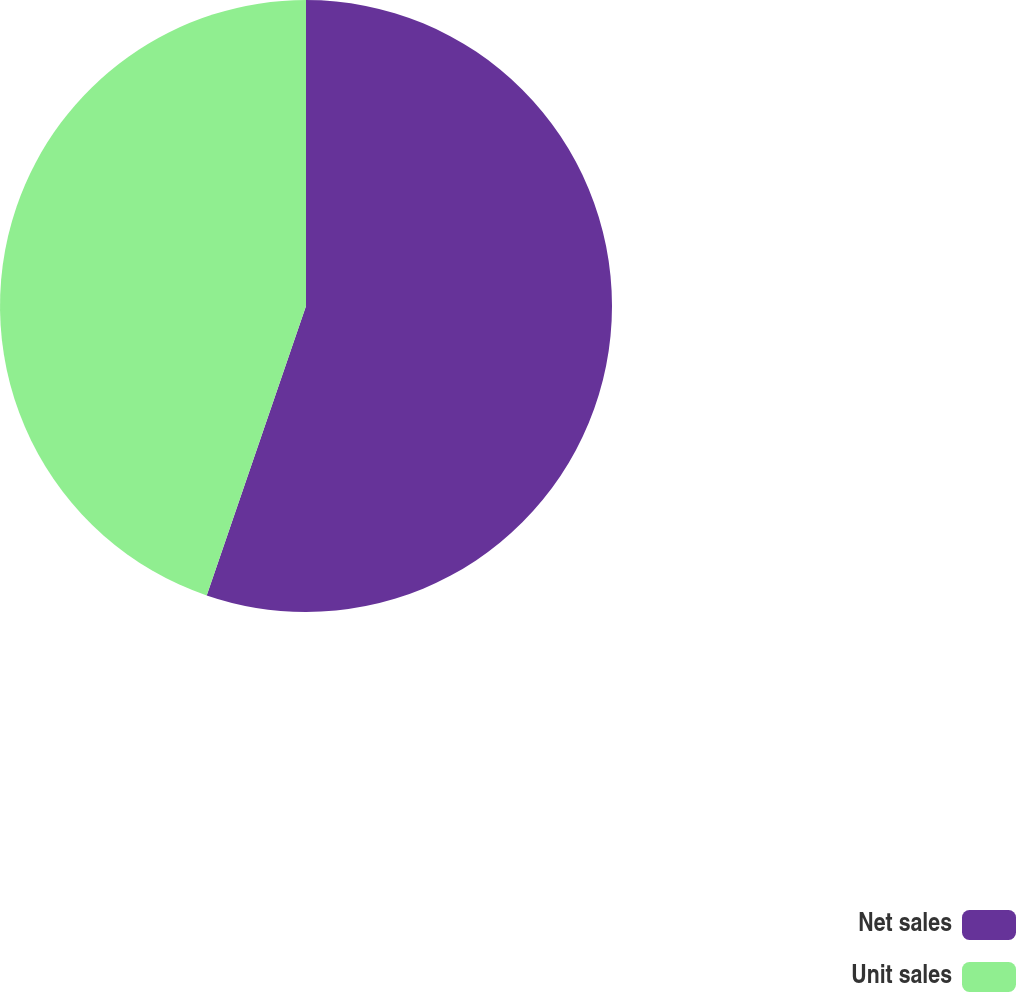Convert chart to OTSL. <chart><loc_0><loc_0><loc_500><loc_500><pie_chart><fcel>Net sales<fcel>Unit sales<nl><fcel>55.26%<fcel>44.74%<nl></chart> 